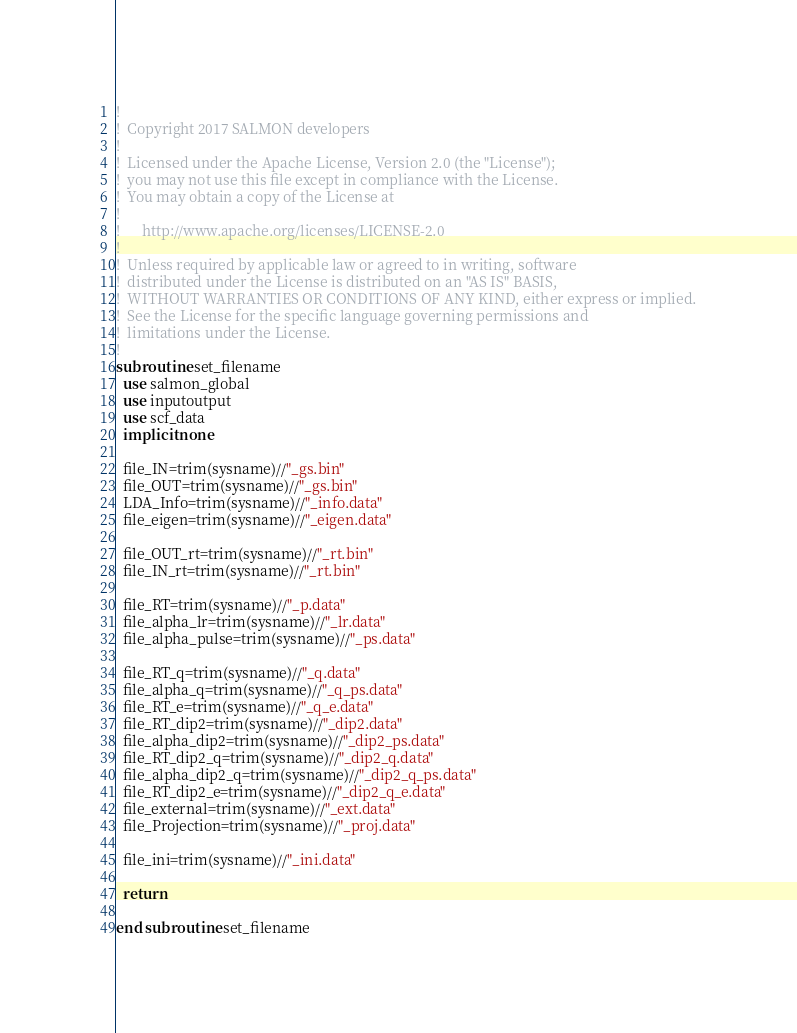Convert code to text. <code><loc_0><loc_0><loc_500><loc_500><_FORTRAN_>!
!  Copyright 2017 SALMON developers
!
!  Licensed under the Apache License, Version 2.0 (the "License");
!  you may not use this file except in compliance with the License.
!  You may obtain a copy of the License at
!
!      http://www.apache.org/licenses/LICENSE-2.0
!
!  Unless required by applicable law or agreed to in writing, software
!  distributed under the License is distributed on an "AS IS" BASIS,
!  WITHOUT WARRANTIES OR CONDITIONS OF ANY KIND, either express or implied.
!  See the License for the specific language governing permissions and
!  limitations under the License.
!
subroutine set_filename
  use salmon_global
  use inputoutput
  use scf_data
  implicit none
  
  file_IN=trim(sysname)//"_gs.bin"
  file_OUT=trim(sysname)//"_gs.bin"
  LDA_Info=trim(sysname)//"_info.data"
  file_eigen=trim(sysname)//"_eigen.data"

  file_OUT_rt=trim(sysname)//"_rt.bin"
  file_IN_rt=trim(sysname)//"_rt.bin"

  file_RT=trim(sysname)//"_p.data"
  file_alpha_lr=trim(sysname)//"_lr.data"
  file_alpha_pulse=trim(sysname)//"_ps.data"

  file_RT_q=trim(sysname)//"_q.data"
  file_alpha_q=trim(sysname)//"_q_ps.data"
  file_RT_e=trim(sysname)//"_q_e.data"
  file_RT_dip2=trim(sysname)//"_dip2.data"
  file_alpha_dip2=trim(sysname)//"_dip2_ps.data"
  file_RT_dip2_q=trim(sysname)//"_dip2_q.data"
  file_alpha_dip2_q=trim(sysname)//"_dip2_q_ps.data"
  file_RT_dip2_e=trim(sysname)//"_dip2_q_e.data"
  file_external=trim(sysname)//"_ext.data"
  file_Projection=trim(sysname)//"_proj.data"
  
  file_ini=trim(sysname)//"_ini.data"

  return

end subroutine set_filename

</code> 